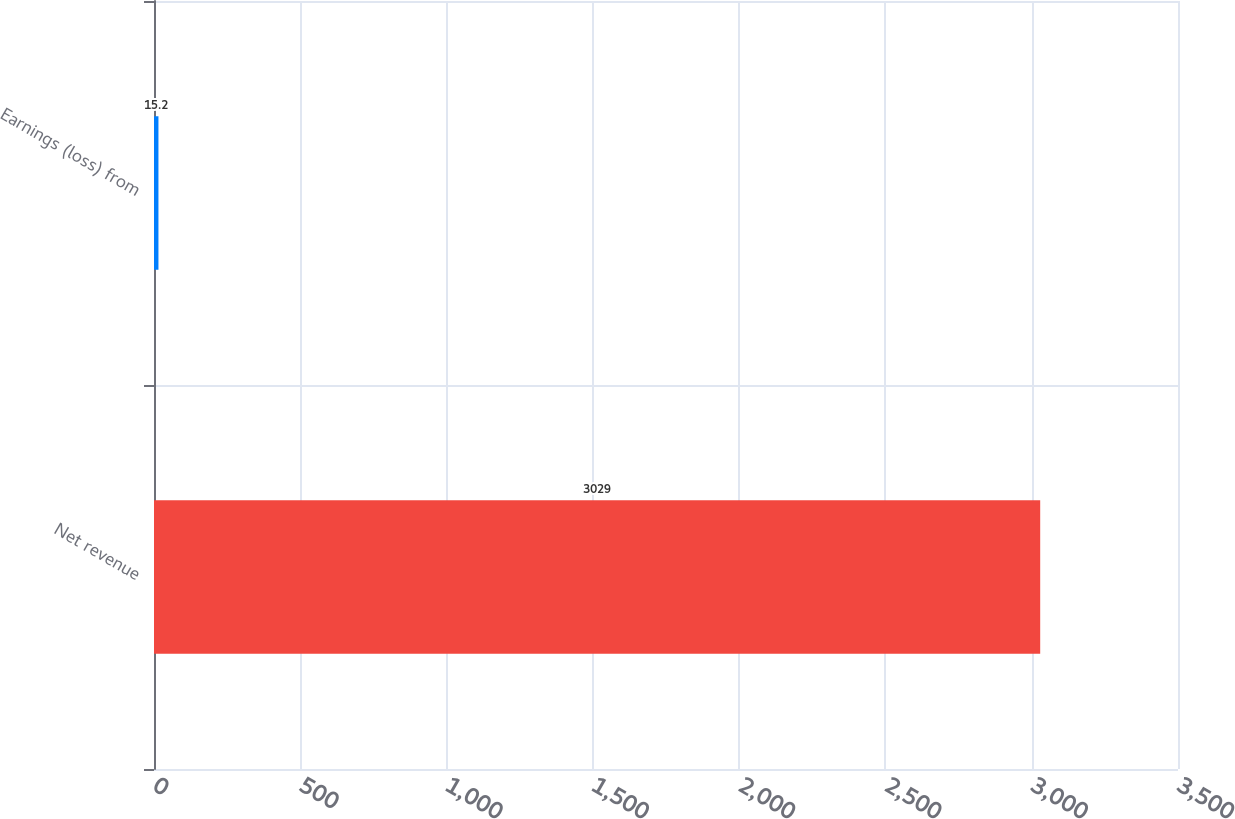<chart> <loc_0><loc_0><loc_500><loc_500><bar_chart><fcel>Net revenue<fcel>Earnings (loss) from<nl><fcel>3029<fcel>15.2<nl></chart> 